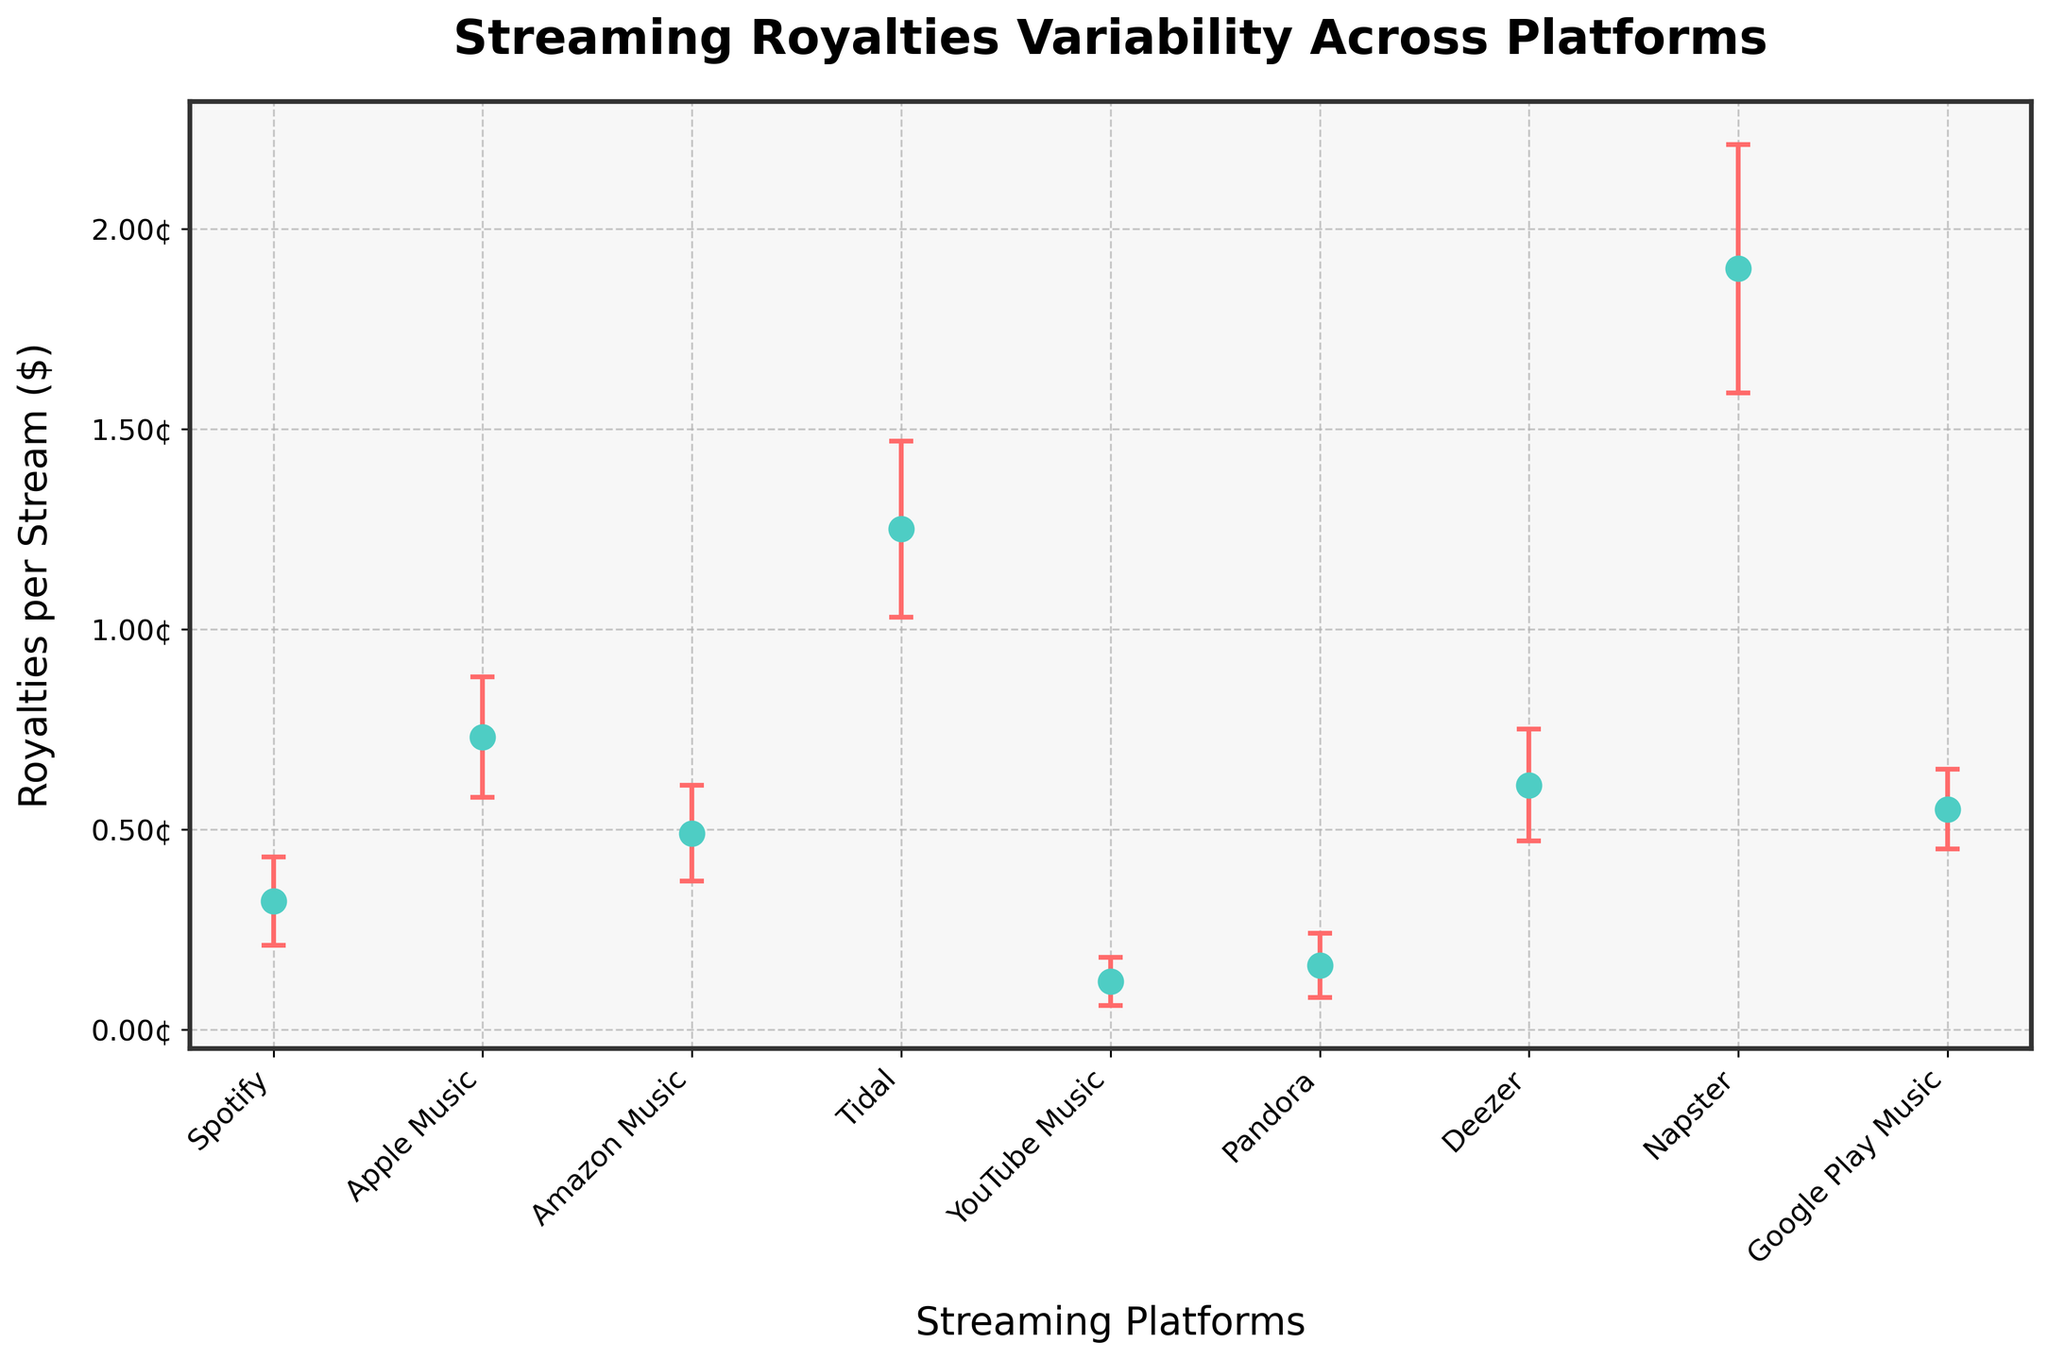What is the title of the figure? The title of the figure is displayed at the top of the plot. It reads: "Streaming Royalties Variability Across Platforms".
Answer: Streaming Royalties Variability Across Platforms Which platform has the highest mean royalties per stream? By looking at the data points on the figure, the platform with the highest mean royalties per stream is Tidal, represented by the highest dot on the y-axis.
Answer: Tidal What is the mean royalties per stream for Apple Music, and what is the error margin? You can locate Apple Music's data point on the plot and observe its corresponding mean royalties per stream and the error bar, which represents the standard deviation. The mean royalties per stream is 0.0073, and the error margin is ±0.0015.
Answer: 0.0073, ±0.0015 Which platform has the smallest variability in royalties? To determine the smallest variability, observe which platform has the smallest error bar. YouTube Music has the smallest error bar, indicating the smallest variability in royalties.
Answer: YouTube Music Compare the mean royalties per stream for Spotify and Amazon Music. Which is higher, and by how much? Locate the data points for Spotify and Amazon Music on the plot. Compare their vertical positions (mean royalties per stream). Amazon Music's mean royalties per stream (0.0049) is higher than Spotify's (0.0032). Subtract Spotify's mean royalties from Amazon Music's: 0.0049 - 0.0032 = 0.0017.
Answer: Amazon Music, by 0.0017 What is the difference in standard deviation of royalties between Napster and Pandora? To find this difference, look at the error bars representing the standard deviations for Napster (0.0031) and Pandora (0.0008). Calculate the difference: 0.0031 - 0.0008 = 0.0023.
Answer: 0.0023 For which platform do the mean royalties fall below 0.002 dollars per stream? Look for the platforms where the data points fall below the 0.002 mark on the y-axis. Both YouTube Music and Pandora have mean royalties below this level.
Answer: YouTube Music and Pandora Which platform has the highest standard deviation in royalties? Identify the platform with the longest error bar if the mean values are similar. Napster has the highest standard deviation, represented by the longest error bar among all platforms.
Answer: Napster 